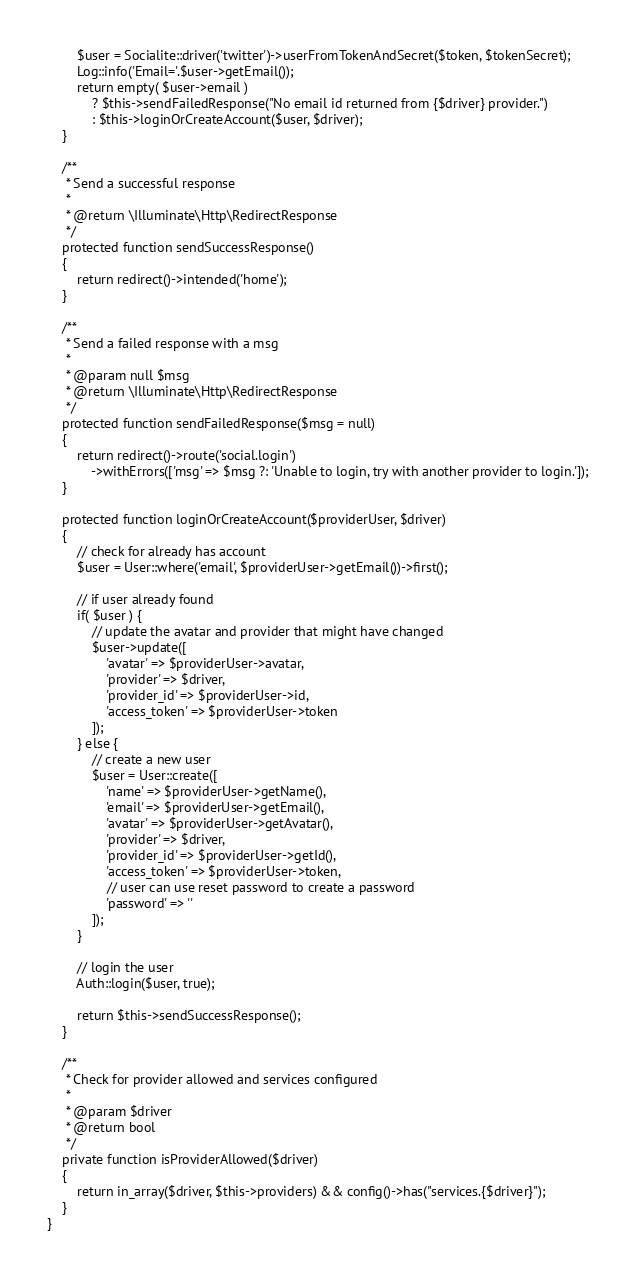<code> <loc_0><loc_0><loc_500><loc_500><_PHP_>		$user = Socialite::driver('twitter')->userFromTokenAndSecret($token, $tokenSecret);
		Log::info('Email='.$user->getEmail());
        return empty( $user->email )
            ? $this->sendFailedResponse("No email id returned from {$driver} provider.")
            : $this->loginOrCreateAccount($user, $driver);
    }

    /**
     * Send a successful response
     *
     * @return \Illuminate\Http\RedirectResponse
     */
    protected function sendSuccessResponse()
    {
        return redirect()->intended('home');
    }

    /**
     * Send a failed response with a msg
     *
     * @param null $msg
     * @return \Illuminate\Http\RedirectResponse
     */
    protected function sendFailedResponse($msg = null)
    {
        return redirect()->route('social.login')
            ->withErrors(['msg' => $msg ?: 'Unable to login, try with another provider to login.']);
    }

    protected function loginOrCreateAccount($providerUser, $driver)
    {
        // check for already has account
        $user = User::where('email', $providerUser->getEmail())->first();

        // if user already found
        if( $user ) {
            // update the avatar and provider that might have changed
            $user->update([
                'avatar' => $providerUser->avatar,
                'provider' => $driver,
                'provider_id' => $providerUser->id,
                'access_token' => $providerUser->token
            ]);
        } else {
            // create a new user
            $user = User::create([
                'name' => $providerUser->getName(),
                'email' => $providerUser->getEmail(),
                'avatar' => $providerUser->getAvatar(),
                'provider' => $driver,
                'provider_id' => $providerUser->getId(),
                'access_token' => $providerUser->token,
                // user can use reset password to create a password
                'password' => ''
            ]);
        }

        // login the user
        Auth::login($user, true);

        return $this->sendSuccessResponse();
    }

    /**
     * Check for provider allowed and services configured
     *
     * @param $driver
     * @return bool
     */
    private function isProviderAllowed($driver)
    {
        return in_array($driver, $this->providers) && config()->has("services.{$driver}");
    }
}
</code> 